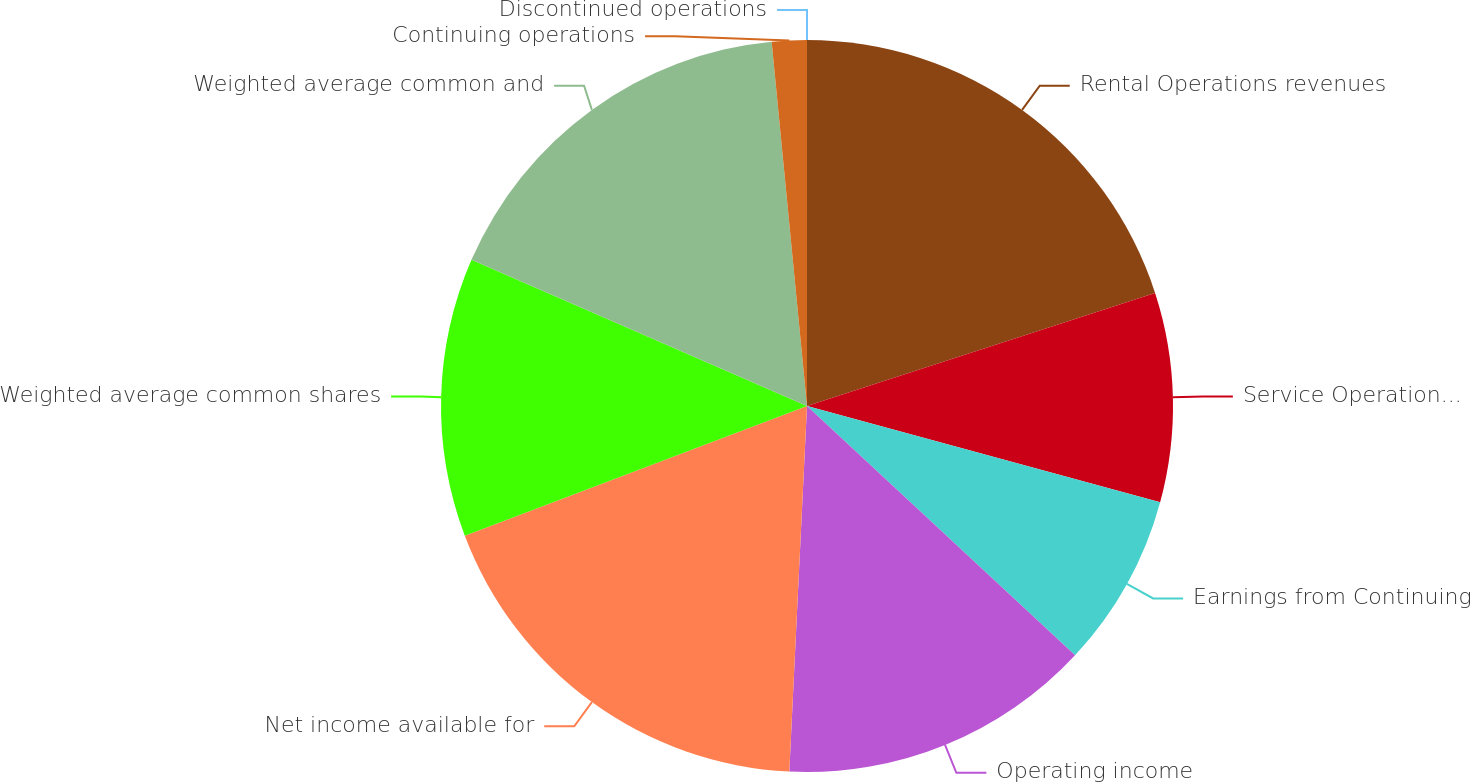Convert chart to OTSL. <chart><loc_0><loc_0><loc_500><loc_500><pie_chart><fcel>Rental Operations revenues<fcel>Service Operations revenues<fcel>Earnings from Continuing<fcel>Operating income<fcel>Net income available for<fcel>Weighted average common shares<fcel>Weighted average common and<fcel>Continuing operations<fcel>Discontinued operations<nl><fcel>20.0%<fcel>9.23%<fcel>7.69%<fcel>13.85%<fcel>18.46%<fcel>12.31%<fcel>16.92%<fcel>1.54%<fcel>0.0%<nl></chart> 